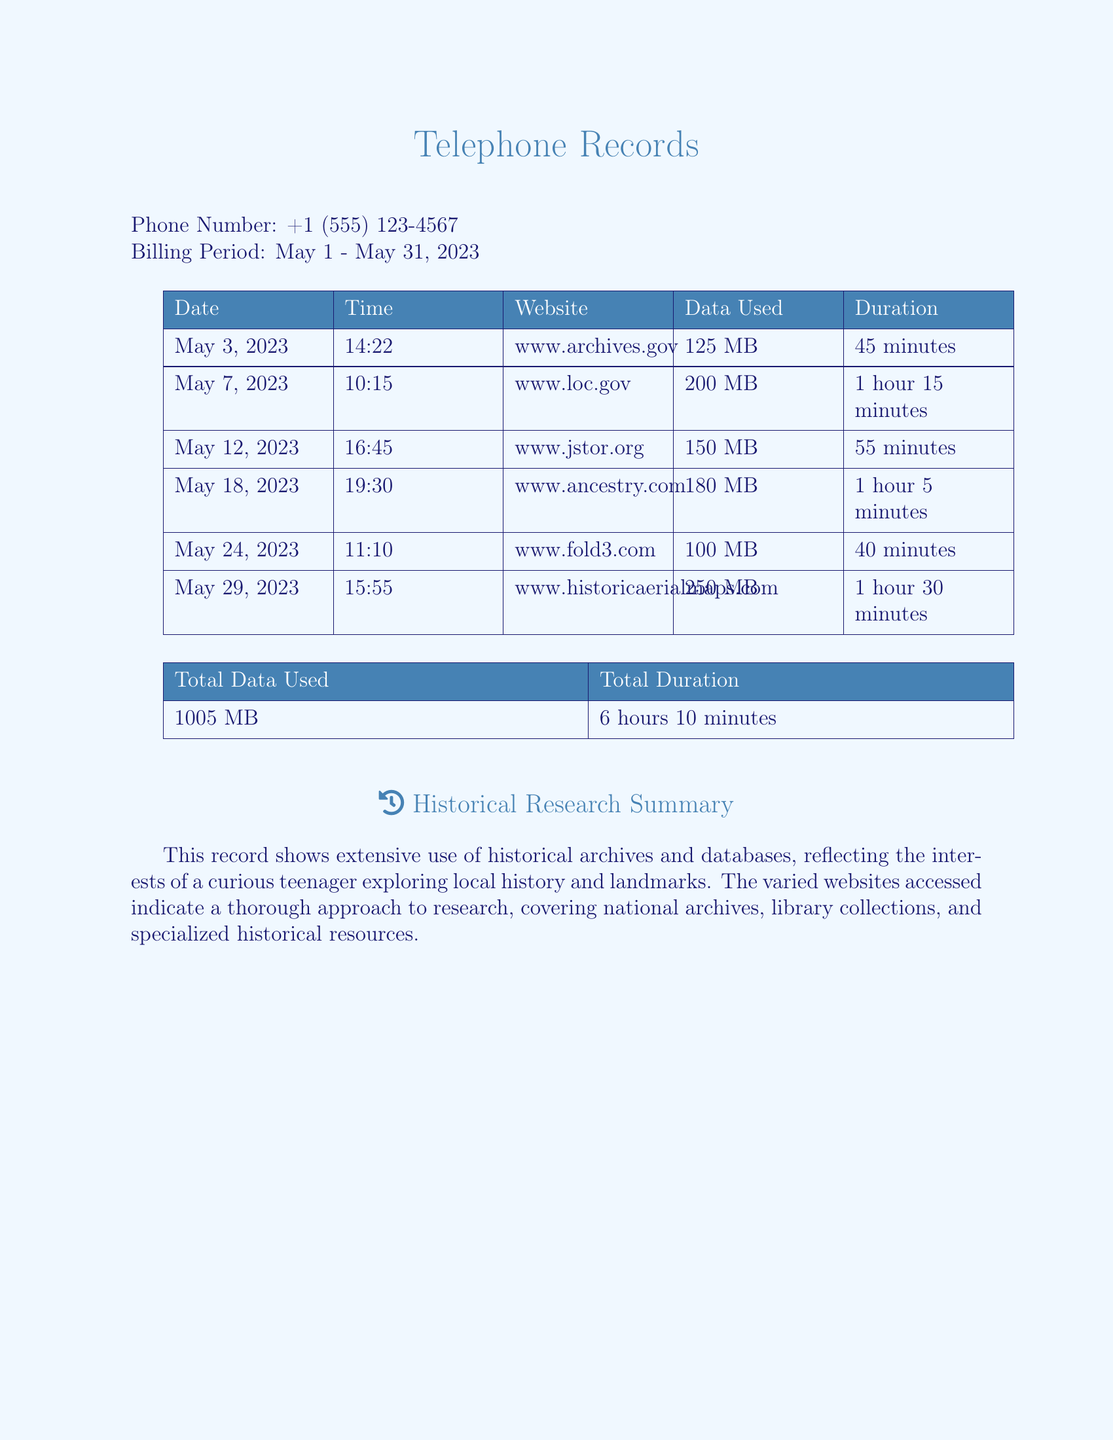What phone number is listed? The document specifies the phone number associated with the records, which is clearly stated at the beginning.
Answer: +1 (555) 123-4567 What was the total data used? The total data used is summarized in a table that aggregates all the data amounts from each entry.
Answer: 1005 MB How many sites were accessed in total? By reviewing the list of websites in the document, I can count the individual entries for sites accessed.
Answer: 6 Which website used the most data? The document provides a detailed list of data usage per website, allowing me to identify the one with the highest data usage.
Answer: www.historicaerialmaps.com What was the date of the first recorded entry? The first entry in the table indicates the date of the initial access, providing the earliest record in the document.
Answer: May 3, 2023 What is the total duration of all activities? The document summarizes the total time spent across multiple entries, which is illustrated in the summary table.
Answer: 6 hours 10 minutes Which website was accessed on May 18, 2023? The document lists the specific websites accessed along with their corresponding dates, allowing for identification of records by date.
Answer: www.ancestry.com How long was the session on www.archives.gov? Each entry specifies the duration of access to each website, allowing me to extract that specific time for this site.
Answer: 45 minutes What type of inquiry does this document represent? The summary remarks highlight the nature of the research, reflecting the inquiries made based on the records.
Answer: Historical research 